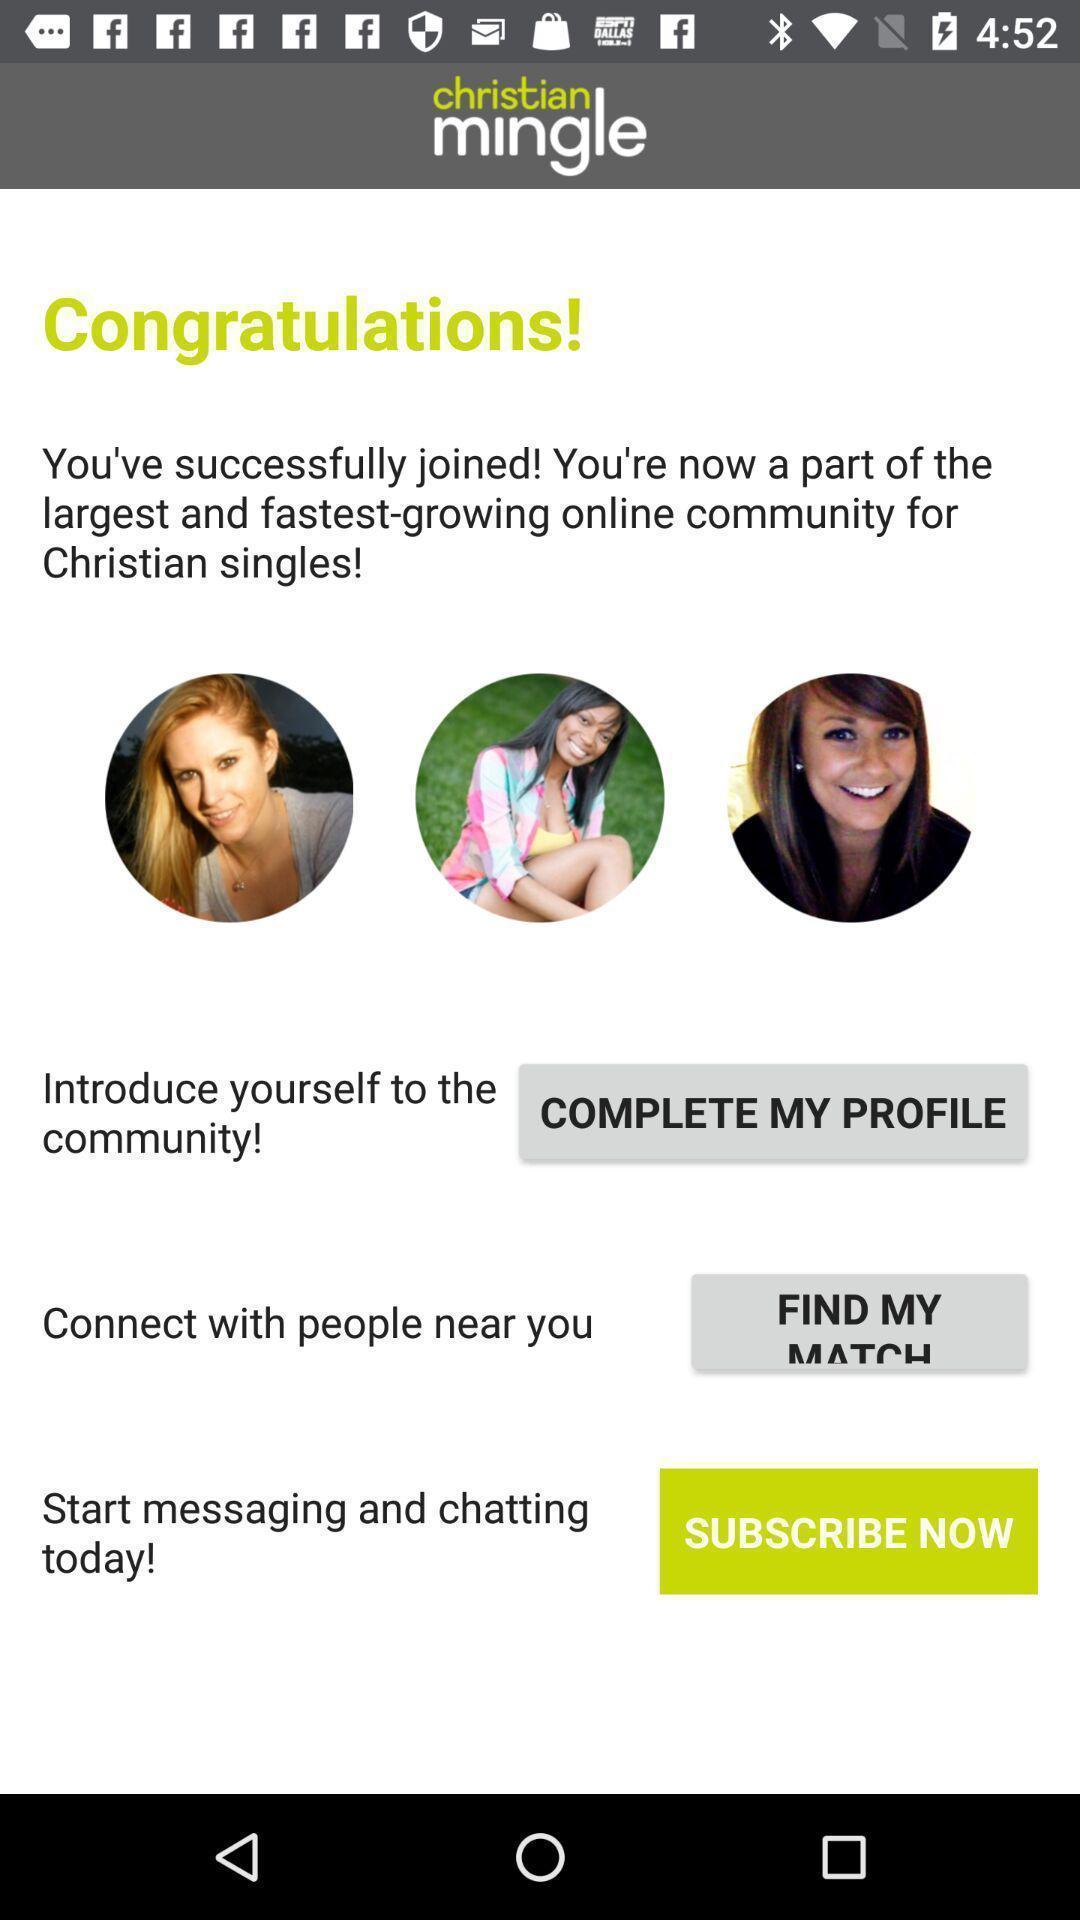What can you discern from this picture? Welcome page of a dating application. 